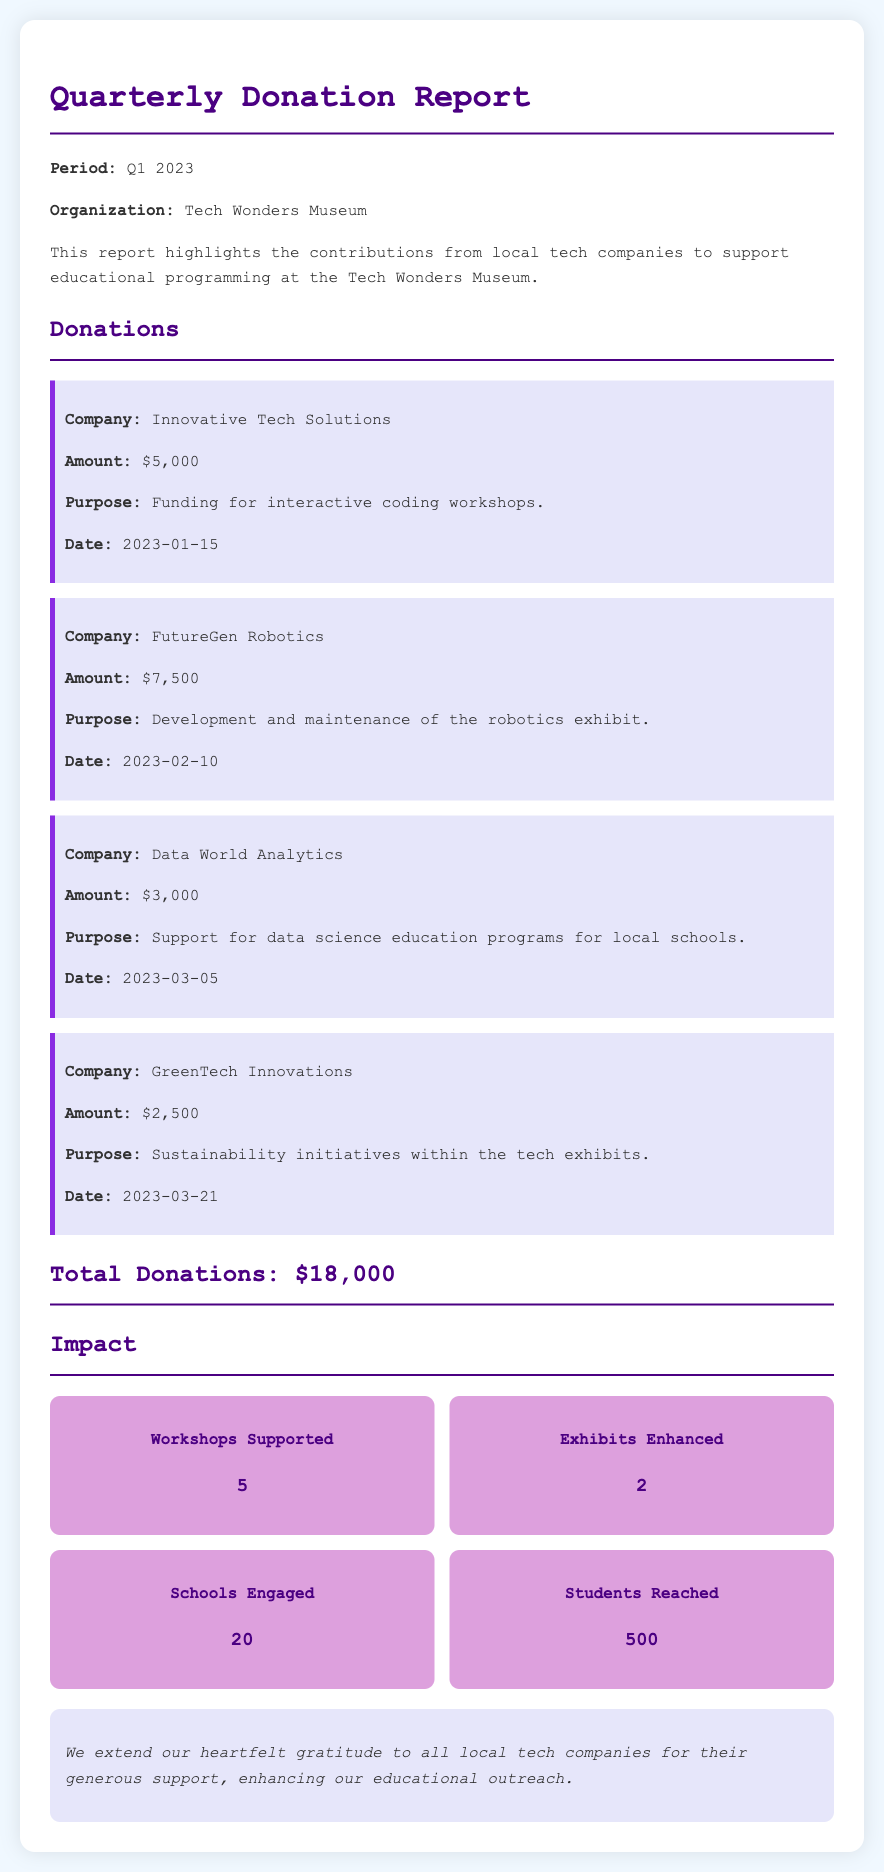What is the total amount of donations? The total amount of donations is stated at the end of the donations section, which sums all the contributions from local tech companies.
Answer: $18,000 Which company donated for robotic exhibit development? The company that donated for the development and maintenance of the robotics exhibit is explicitly mentioned in one of the donation items.
Answer: FutureGen Robotics How many workshops are supported as a result of the donations? The number of workshops supported is shown in the impact section of the report.
Answer: 5 What was the donation amount from Data World Analytics? The donation amount from Data World Analytics is specified in the document under their donation details.
Answer: $3,000 What is the purpose of the donation from GreenTech Innovations? The purpose of the donation from GreenTech Innovations is described in detail within their donation item.
Answer: Sustainability initiatives within the tech exhibits How many schools were engaged through the donations? The number of schools engaged is outlined in the impact section, which summarizes the outreach efforts.
Answer: 20 Which date was the donation from Innovative Tech Solutions made? The date for the donation from Innovative Tech Solutions is clearly listed in their donation details.
Answer: 2023-01-15 What kind of appreciation is expressed in the document? The appreciation section conveys gratitude towards local tech companies for their support, emphasizing the impact of their contributions.
Answer: Heartfelt gratitude 